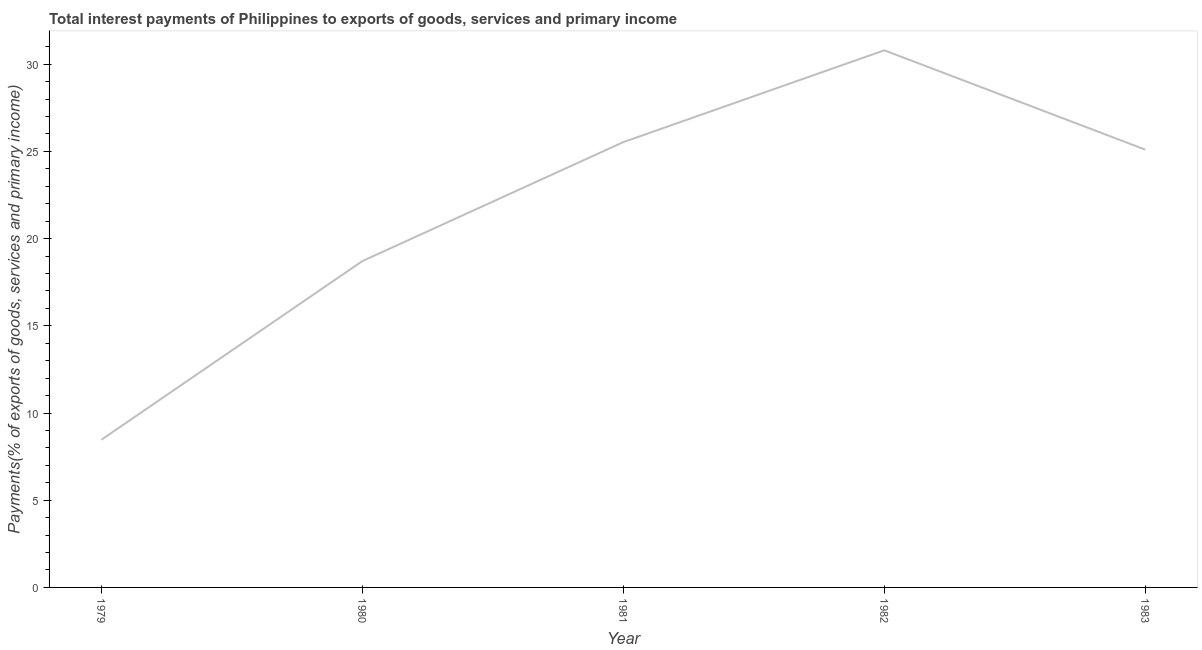What is the total interest payments on external debt in 1982?
Keep it short and to the point. 30.8. Across all years, what is the maximum total interest payments on external debt?
Your answer should be compact. 30.8. Across all years, what is the minimum total interest payments on external debt?
Ensure brevity in your answer.  8.46. In which year was the total interest payments on external debt maximum?
Offer a terse response. 1982. In which year was the total interest payments on external debt minimum?
Ensure brevity in your answer.  1979. What is the sum of the total interest payments on external debt?
Your response must be concise. 108.61. What is the difference between the total interest payments on external debt in 1980 and 1983?
Your response must be concise. -6.39. What is the average total interest payments on external debt per year?
Make the answer very short. 21.72. What is the median total interest payments on external debt?
Offer a very short reply. 25.1. In how many years, is the total interest payments on external debt greater than 29 %?
Make the answer very short. 1. What is the ratio of the total interest payments on external debt in 1980 to that in 1983?
Your answer should be very brief. 0.75. Is the difference between the total interest payments on external debt in 1981 and 1983 greater than the difference between any two years?
Provide a short and direct response. No. What is the difference between the highest and the second highest total interest payments on external debt?
Your answer should be compact. 5.26. Is the sum of the total interest payments on external debt in 1979 and 1981 greater than the maximum total interest payments on external debt across all years?
Your answer should be compact. Yes. What is the difference between the highest and the lowest total interest payments on external debt?
Your answer should be very brief. 22.33. How many lines are there?
Keep it short and to the point. 1. How many years are there in the graph?
Offer a very short reply. 5. Are the values on the major ticks of Y-axis written in scientific E-notation?
Offer a terse response. No. Does the graph contain any zero values?
Your response must be concise. No. What is the title of the graph?
Provide a succinct answer. Total interest payments of Philippines to exports of goods, services and primary income. What is the label or title of the X-axis?
Keep it short and to the point. Year. What is the label or title of the Y-axis?
Your answer should be very brief. Payments(% of exports of goods, services and primary income). What is the Payments(% of exports of goods, services and primary income) in 1979?
Your response must be concise. 8.46. What is the Payments(% of exports of goods, services and primary income) in 1980?
Give a very brief answer. 18.71. What is the Payments(% of exports of goods, services and primary income) of 1981?
Give a very brief answer. 25.53. What is the Payments(% of exports of goods, services and primary income) of 1982?
Your answer should be compact. 30.8. What is the Payments(% of exports of goods, services and primary income) in 1983?
Ensure brevity in your answer.  25.1. What is the difference between the Payments(% of exports of goods, services and primary income) in 1979 and 1980?
Provide a short and direct response. -10.25. What is the difference between the Payments(% of exports of goods, services and primary income) in 1979 and 1981?
Your answer should be compact. -17.07. What is the difference between the Payments(% of exports of goods, services and primary income) in 1979 and 1982?
Offer a terse response. -22.33. What is the difference between the Payments(% of exports of goods, services and primary income) in 1979 and 1983?
Make the answer very short. -16.64. What is the difference between the Payments(% of exports of goods, services and primary income) in 1980 and 1981?
Give a very brief answer. -6.82. What is the difference between the Payments(% of exports of goods, services and primary income) in 1980 and 1982?
Keep it short and to the point. -12.09. What is the difference between the Payments(% of exports of goods, services and primary income) in 1980 and 1983?
Your response must be concise. -6.39. What is the difference between the Payments(% of exports of goods, services and primary income) in 1981 and 1982?
Provide a short and direct response. -5.26. What is the difference between the Payments(% of exports of goods, services and primary income) in 1981 and 1983?
Your answer should be compact. 0.43. What is the difference between the Payments(% of exports of goods, services and primary income) in 1982 and 1983?
Give a very brief answer. 5.7. What is the ratio of the Payments(% of exports of goods, services and primary income) in 1979 to that in 1980?
Your response must be concise. 0.45. What is the ratio of the Payments(% of exports of goods, services and primary income) in 1979 to that in 1981?
Make the answer very short. 0.33. What is the ratio of the Payments(% of exports of goods, services and primary income) in 1979 to that in 1982?
Offer a terse response. 0.28. What is the ratio of the Payments(% of exports of goods, services and primary income) in 1979 to that in 1983?
Your response must be concise. 0.34. What is the ratio of the Payments(% of exports of goods, services and primary income) in 1980 to that in 1981?
Provide a succinct answer. 0.73. What is the ratio of the Payments(% of exports of goods, services and primary income) in 1980 to that in 1982?
Provide a short and direct response. 0.61. What is the ratio of the Payments(% of exports of goods, services and primary income) in 1980 to that in 1983?
Offer a terse response. 0.74. What is the ratio of the Payments(% of exports of goods, services and primary income) in 1981 to that in 1982?
Your answer should be compact. 0.83. What is the ratio of the Payments(% of exports of goods, services and primary income) in 1981 to that in 1983?
Your response must be concise. 1.02. What is the ratio of the Payments(% of exports of goods, services and primary income) in 1982 to that in 1983?
Offer a terse response. 1.23. 